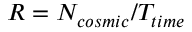Convert formula to latex. <formula><loc_0><loc_0><loc_500><loc_500>R = N _ { \cos m i c } / T _ { t i m e }</formula> 